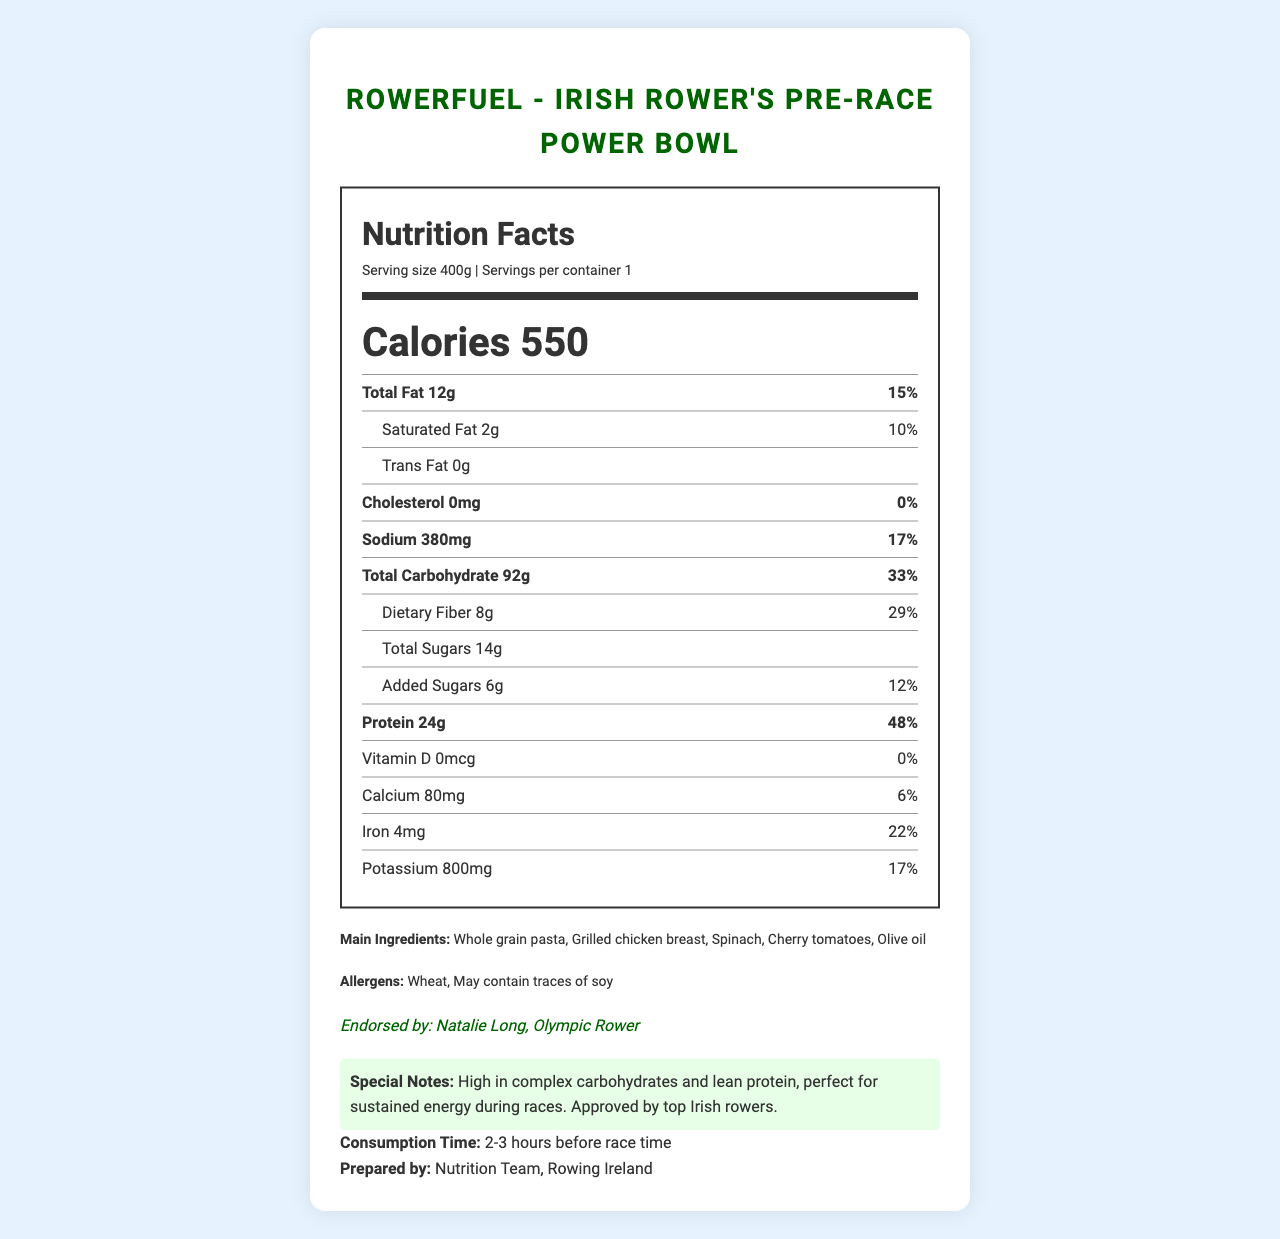What is the serving size of the Irish Rower's Pre-Race Power Bowl? The serving size is mentioned at the beginning of the nutrition label under 'Serving size'.
Answer: 400g How many calories does one serving of the Irish Rower's Pre-Race Power Bowl contain? The number of calories is prominently displayed in the "Calories" section of the nutrition label.
Answer: 550 What is the main endorsement provided for the Irish Rower's Pre-Race Power Bowl? The endorsement is included in the document near the bottom, stating "Endorsed by: Natalie Long, Olympic Rower".
Answer: Endorsed by Natalie Long, Olympic Rower What is the consumption time recommended for the Irish Rower's Pre-Race Power Bowl? The consumption time is stated at the bottom of the document near 'Consumption Time'.
Answer: 2-3 hours before race time Which ingredient listed may cause allergen concerns, especially for people with soy allergies? The document lists allergens near the end, including "May contain traces of soy".
Answer: May contain traces of soy What is the total amount of protein per serving? The label includes a line item for protein, specifying the amount as 24g.
Answer: 24g What is the percent daily value for dietary fiber in this meal? The percent daily value for dietary fiber is listed under 'Dietary Fiber' as 29%.
Answer: 29% True or False: The Irish Rower's Pre-Race Power Bowl contains trans fat. The document specifically mentions "Trans Fat 0g".
Answer: False Which of the following is NOT a main ingredient in the Irish Rower's Pre-Race Power Bowl?
A. Whole grain pasta
B. Spinach
C. Kale
D. Olive oil The listed main ingredients include Whole grain pasta, Spinach, Cherry tomatoes, Olive oil, and Grilled chicken breast but do not mention Kale.
Answer: C. Kale According to the nutrition label, how much sodium is present in one serving of the Irish Rower's Pre-Race Power Bowl?
1. 100mg
2. 250mg
3. 380mg
4. 500mg The amount of sodium is clearly specified as 380mg.
Answer: 3. 380mg Summarize the main purpose and content of the Irish Rower's Pre-Race Power Bowl document. The document includes the brand and product name, complete nutritional information, main ingredients, allergen information, an endorsement from an Olympic rower, special notes, recommended consumption time, and preparation details.
Answer: The document provides a detailed Nutrition Facts Label for the Irish Rower's Pre-Race Power Bowl, a meal designed for rowers. It lists nutritional information, ingredients, allergens, endorsement by Olympic Rower Natalie Long, and consumption advice. Describe the special nutritional feature highlighted in the document for the Irish Rower's Pre-Race Power Bowl. The document notes in the Special Notes section that the meal is high in complex carbohydrates and lean protein, making it ideal for sustained energy during races.
Answer: High in complex carbohydrates and lean protein How much calcium is provided per serving, and what percent of the daily value does this represent? The calcium content is listed as 80mg and represents 6% of the daily value.
Answer: 80mg, 6% Which nutrient has the highest percent daily value? The protein content per serving has the highest percent daily value at 48%.
Answer: Protein What are the key dietary concerns related to the allergens in this product? The allergens section mentions that the product contains wheat and may contain traces of soy.
Answer: Wheat, May contain traces of soy Who is responsible for preparing the Irish Rower's Pre-Race Power Bowl? The document states that it is prepared by the Nutrition Team at Rowing Ireland.
Answer: Nutrition Team, Rowing Ireland Why is the detailed distribution of micronutrients such as Vitamin D and Calcium mentioned in the document important for athletes? The document lists the amounts, but it doesn't explain their specific importance for athletes.
Answer: Not enough information How many grams of sugar come from added sugars in the Irish Rower's Pre-Race Power Bowl? The document specifies that out of the total 14g of sugars, 6g come from added sugars.
Answer: 6g 